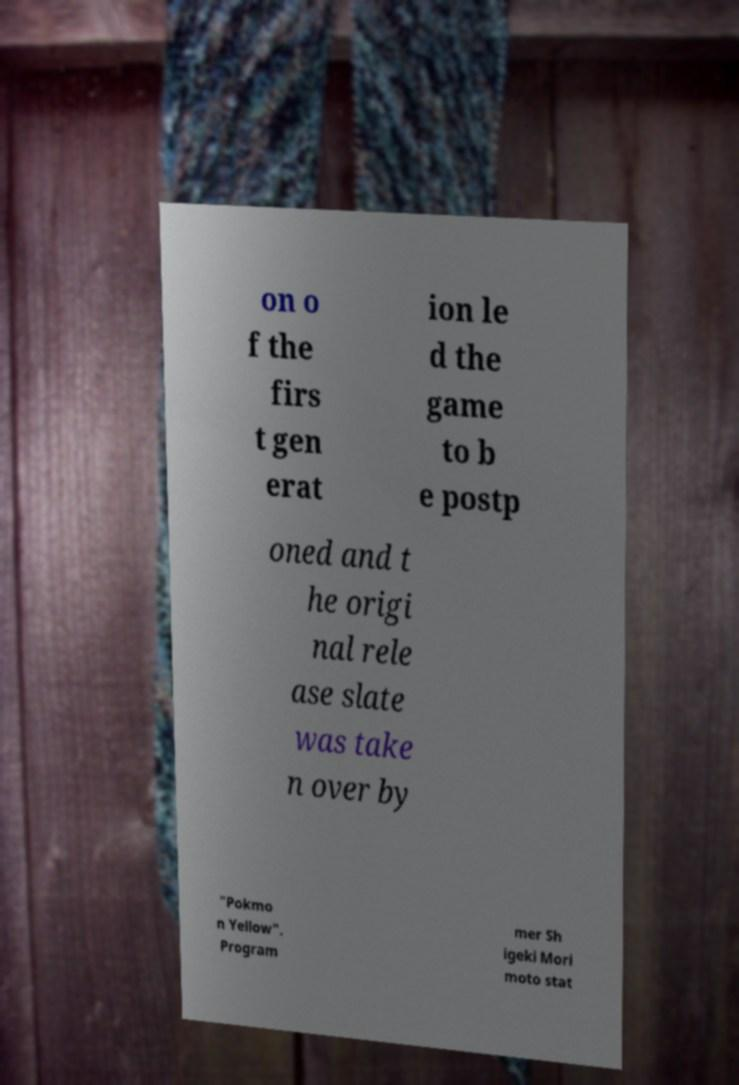I need the written content from this picture converted into text. Can you do that? on o f the firs t gen erat ion le d the game to b e postp oned and t he origi nal rele ase slate was take n over by "Pokmo n Yellow". Program mer Sh igeki Mori moto stat 